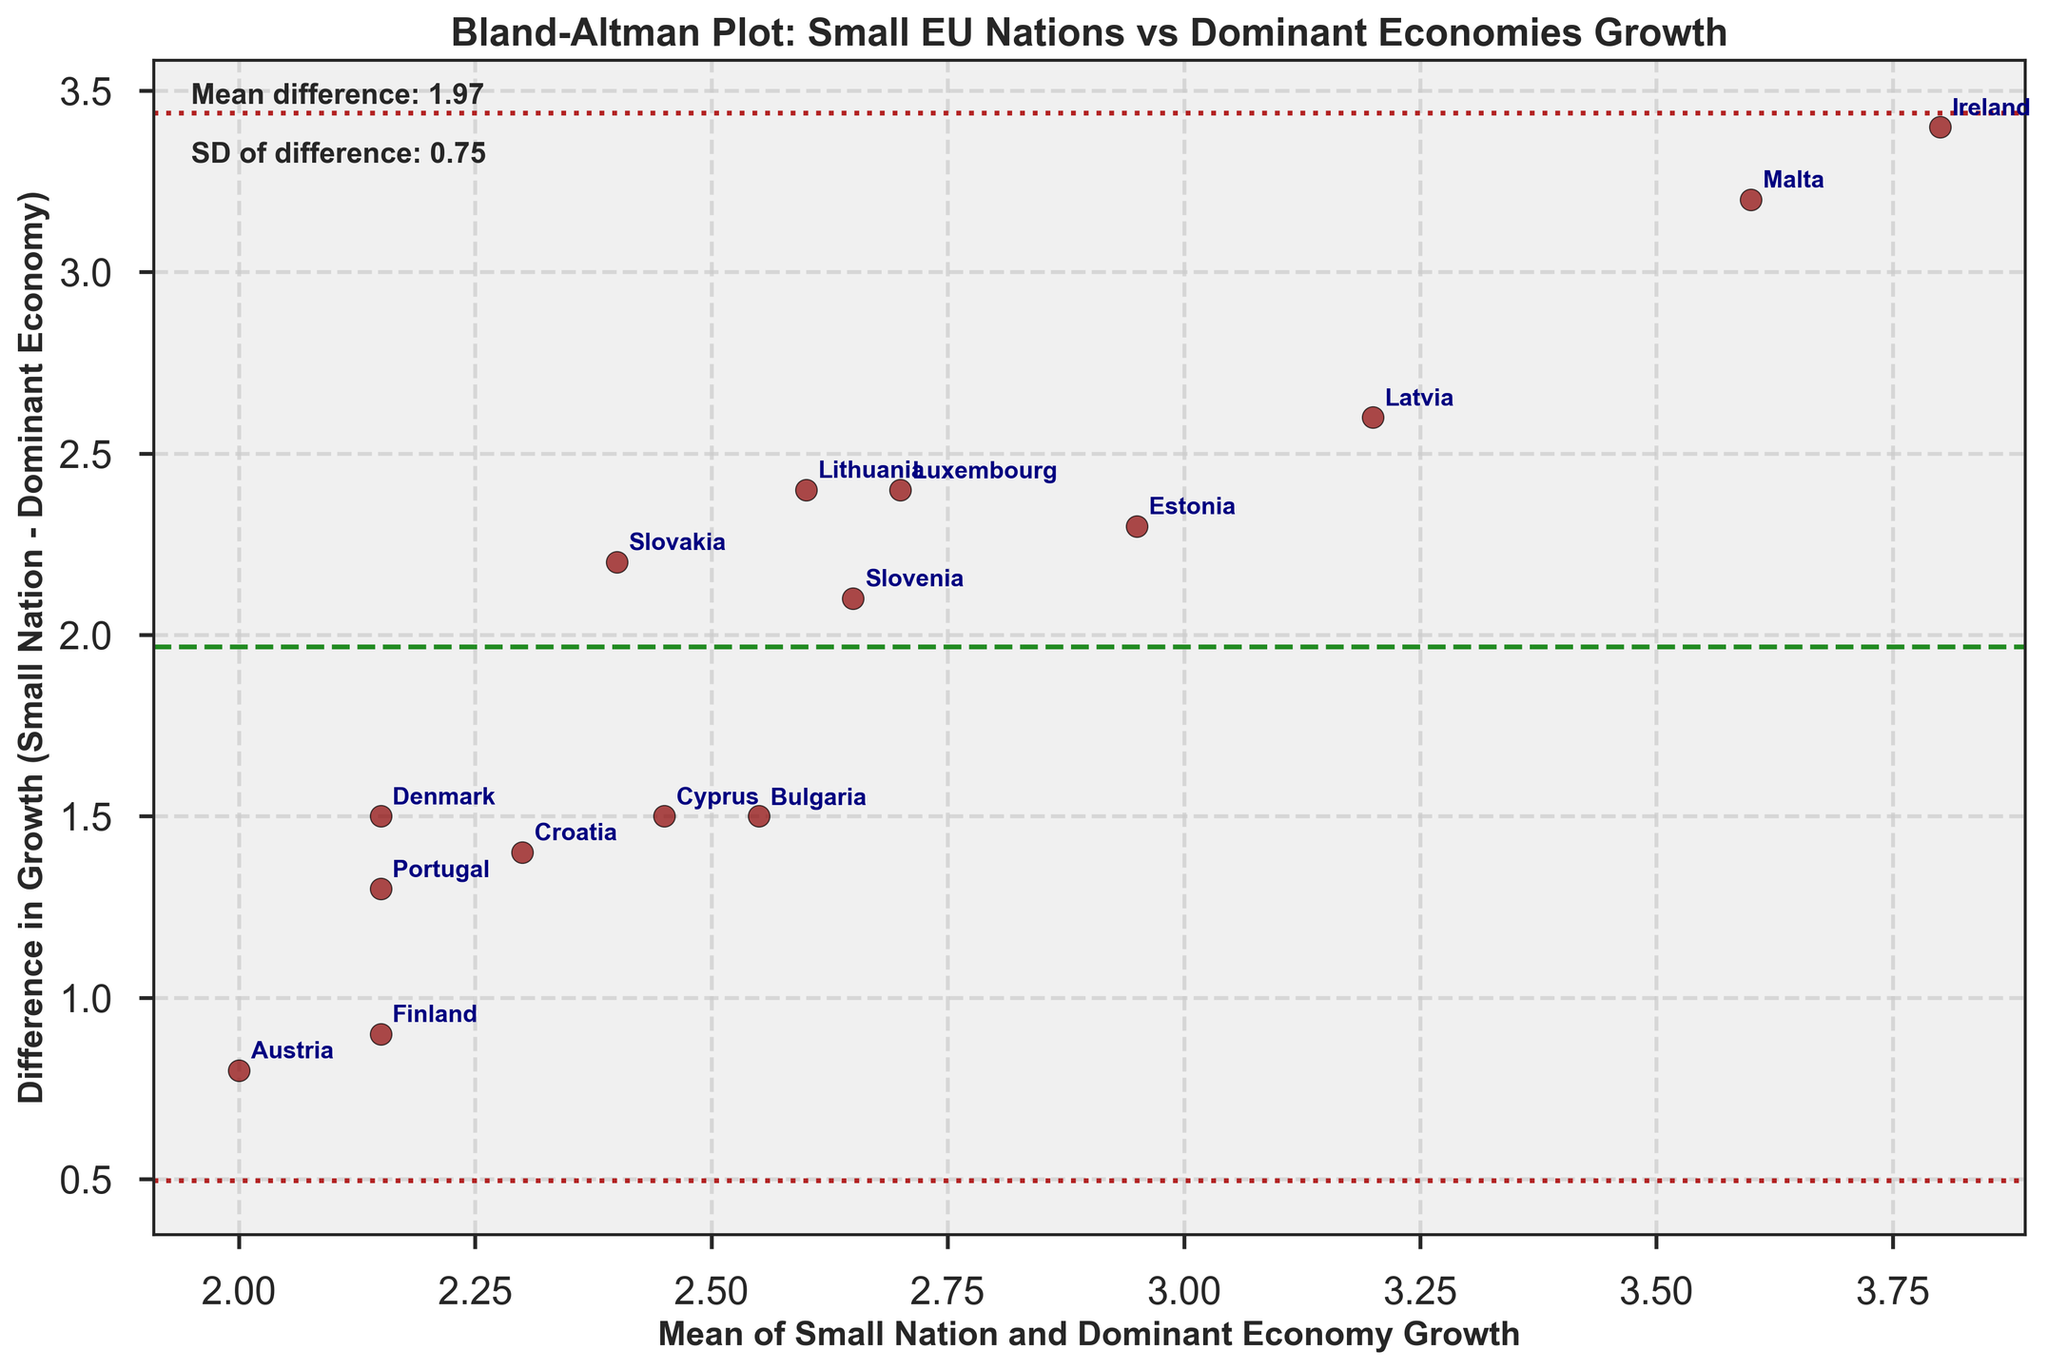What is the title of the figure? The title of the figure is written at the top of the plot.
Answer: Bland-Altman Plot: Small EU Nations vs Dominant Economies Growth How many data points are plotted on the figure? Count the number of points scattered on the plot.
Answer: 15 What does the horizontal green dashed line represent? The figure includes a green dashed line; this generally denotes the mean difference in Bland-Altman plots.
Answer: Mean difference Which country has the largest positive difference in growth rates? Locate the point with the highest vertical value in the positive direction and identify the country name annotated next to it.
Answer: Ireland What is the mean difference in growth rates as indicated on the plot? Read the text placed near the lines showing the mean difference.
Answer: 1.87 What is the standard deviation of the differences shown on the plot? Read the text placed near the lines showing the standard deviation of differences.
Answer: 0.78 Which two countries have the smallest difference in growth rates? Identify the two points closest to the horizontal line representing zero difference; check their annotations.
Answer: Finland and Austria How many countries show a positive difference in growth rates vs dominant economies? Count the number of points above the horizontal line representing zero difference.
Answer: 12 What are the values for the upper and lower lines indicating 1.96 standard deviations from the mean difference? Identify the positions of the dotted red lines above and below the mean difference line and read the corresponding values.
Answer: 3.39 and 0.35 Which country has the lowest average growth rate between small nation and dominant economy growth? Identify the point with the smallest value on the horizontal axis and read the annotated country name.
Answer: Austria 